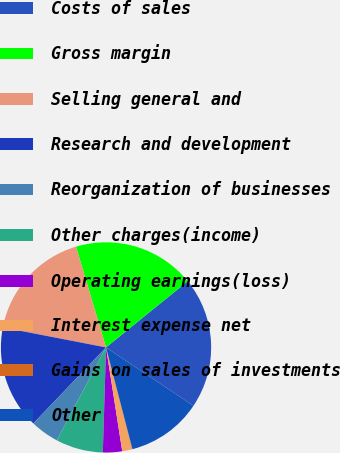Convert chart. <chart><loc_0><loc_0><loc_500><loc_500><pie_chart><fcel>Costs of sales<fcel>Gross margin<fcel>Selling general and<fcel>Research and development<fcel>Reorganization of businesses<fcel>Other charges(income)<fcel>Operating earnings(loss)<fcel>Interest expense net<fcel>Gains on sales of investments<fcel>Other<nl><fcel>20.21%<fcel>18.77%<fcel>17.34%<fcel>15.9%<fcel>4.39%<fcel>7.27%<fcel>2.95%<fcel>1.51%<fcel>0.07%<fcel>11.58%<nl></chart> 